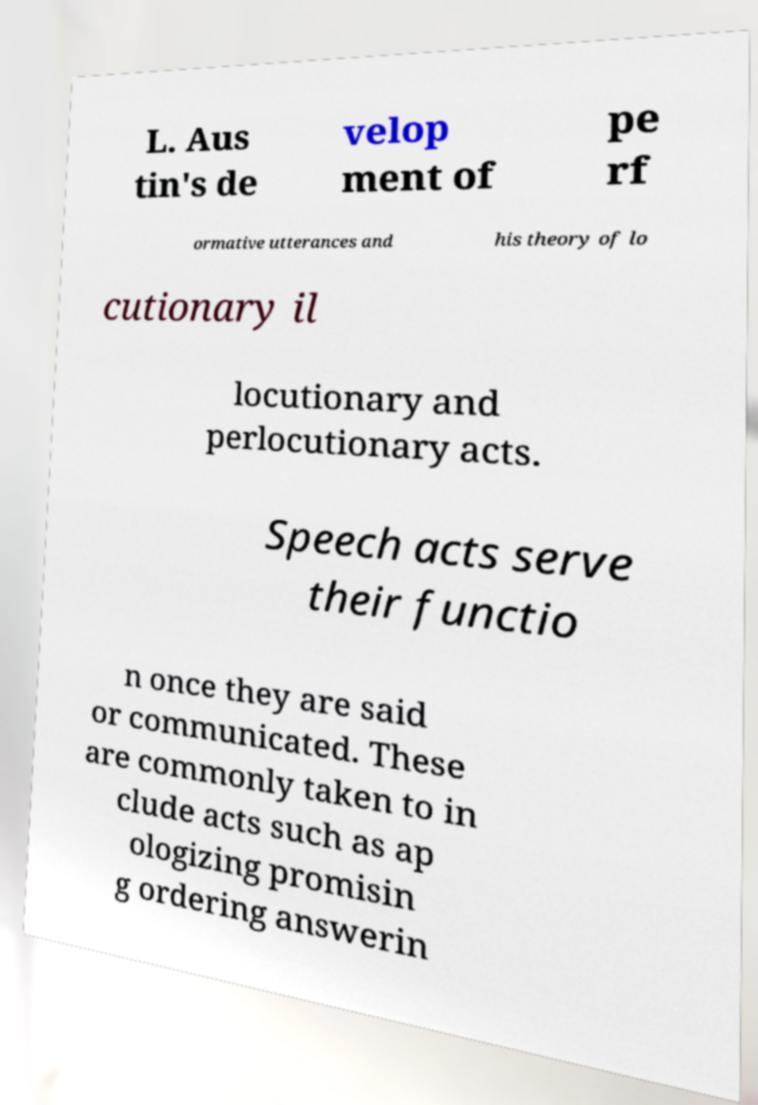There's text embedded in this image that I need extracted. Can you transcribe it verbatim? L. Aus tin's de velop ment of pe rf ormative utterances and his theory of lo cutionary il locutionary and perlocutionary acts. Speech acts serve their functio n once they are said or communicated. These are commonly taken to in clude acts such as ap ologizing promisin g ordering answerin 